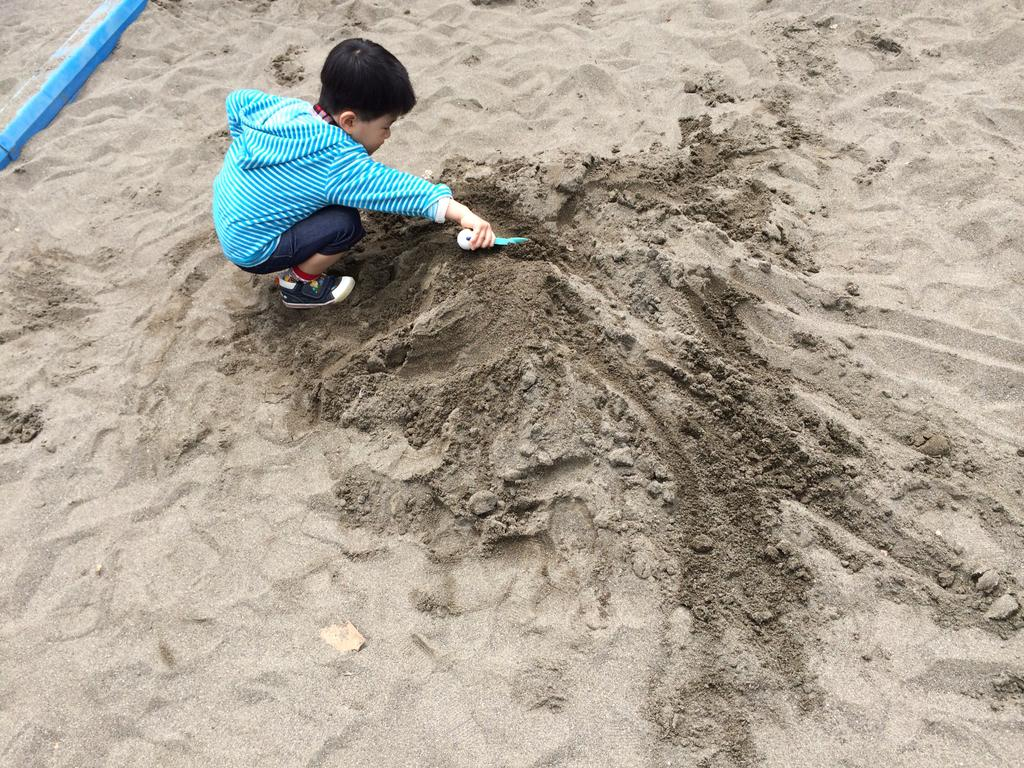What is the main subject of the image? The main subject of the image is a boy. What is the boy doing in the image? The boy is playing with sand. What color is the boy's sweater? The boy is wearing a blue sweater. What type of footwear is the boy wearing? The boy is wearing black shoes. What type of jam is the boy spreading on the top of the sand in the image? There is no jam present in the image, and the boy is not spreading anything on the sand. What type of trade is the boy participating in with the sand in the image? There is no trade present in the image; the boy is simply playing with the sand. 